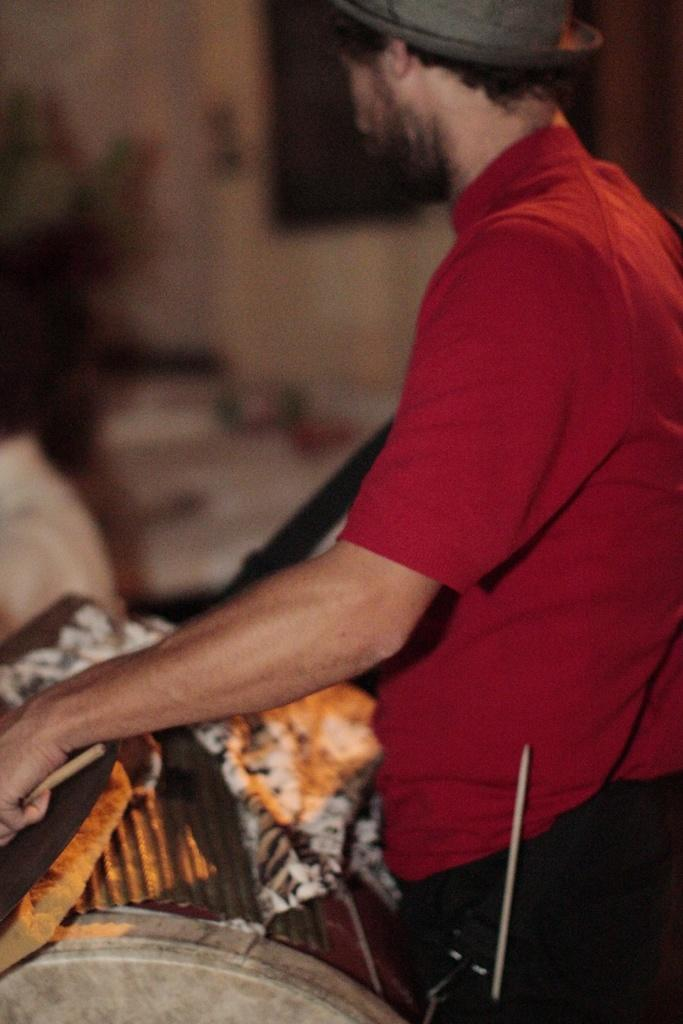What is the main subject of the image? There is a man standing in the image. Can you describe the man's attire? The man is wearing clothes and a hat. What is the man holding in his hand? The man is holding drum sticks in his hand. What else can be seen in the image besides the man? There is a musical instrument in the image. How would you describe the background of the image? The background of the image is blurred. What type of insurance policy does the man have for his drum set in the image? There is no information about insurance policies or drum sets in the image; it only shows a man holding drum sticks and a musical instrument. 